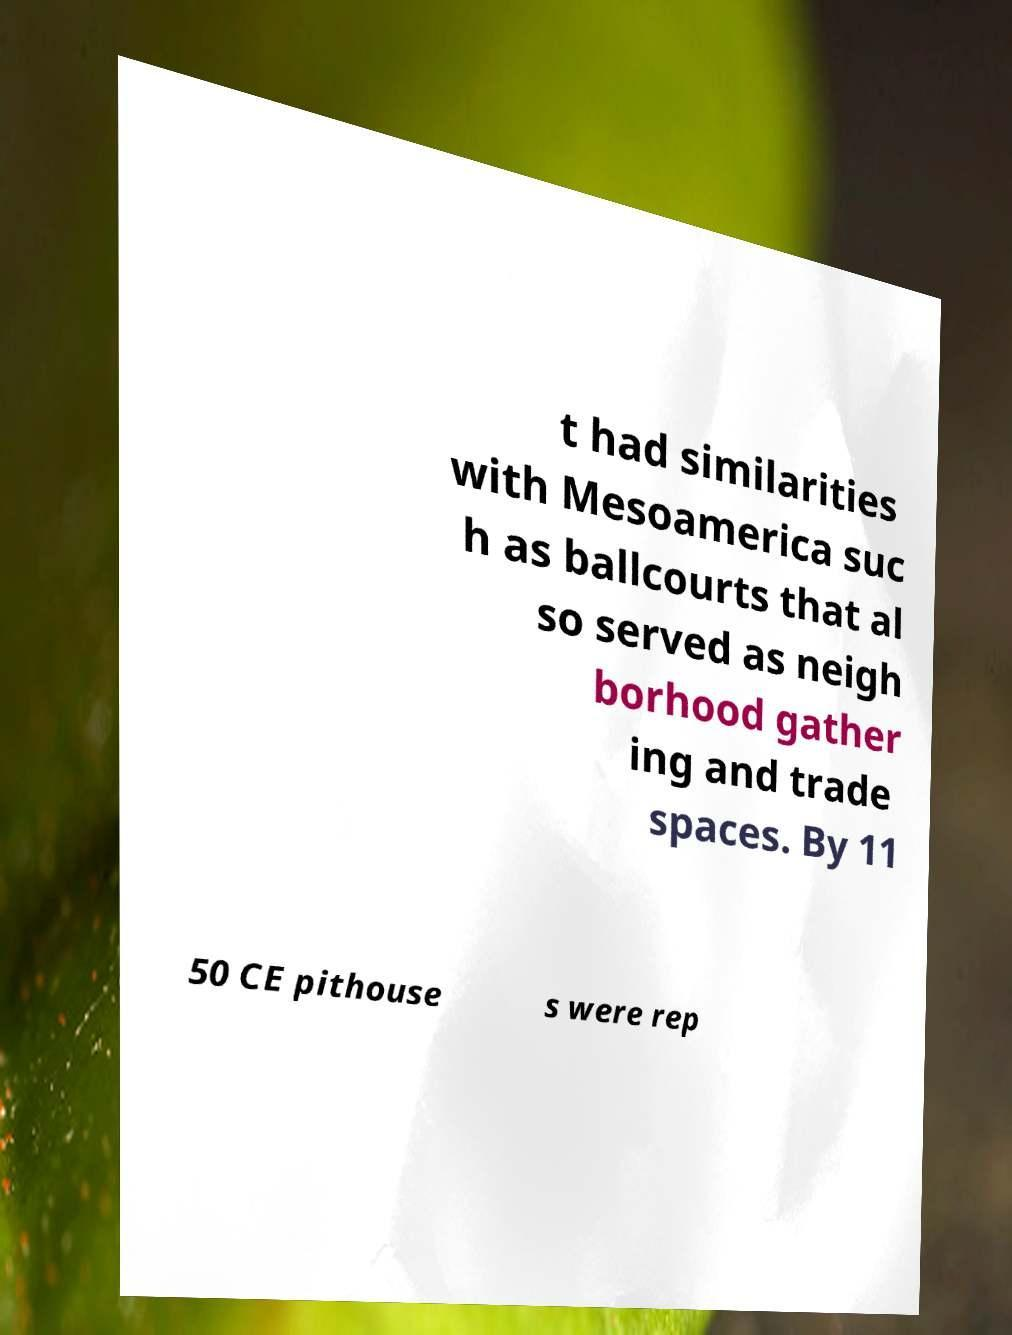What messages or text are displayed in this image? I need them in a readable, typed format. t had similarities with Mesoamerica suc h as ballcourts that al so served as neigh borhood gather ing and trade spaces. By 11 50 CE pithouse s were rep 